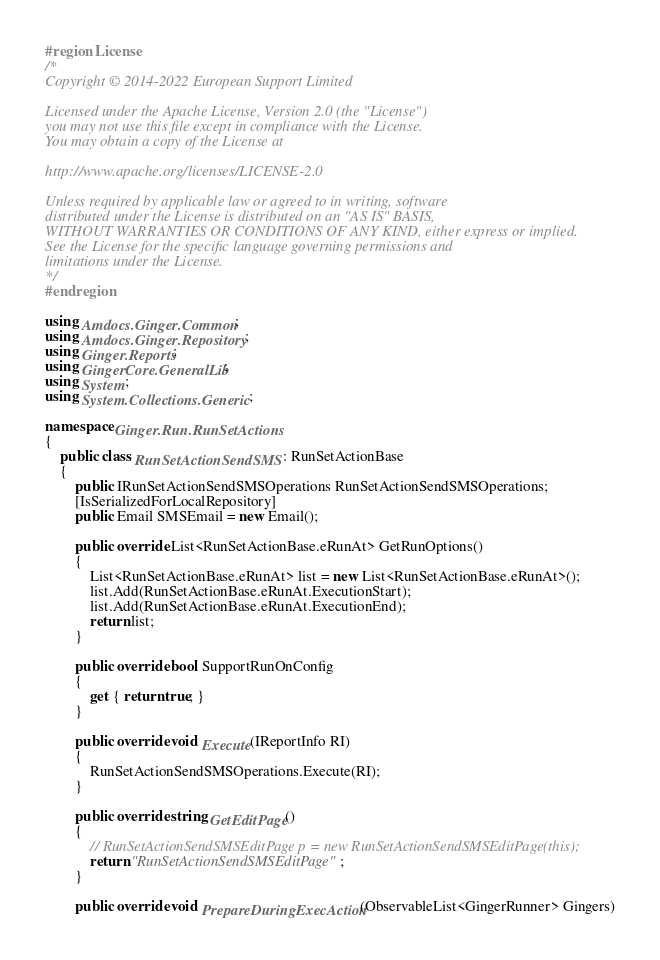<code> <loc_0><loc_0><loc_500><loc_500><_C#_>#region License
/*
Copyright © 2014-2022 European Support Limited

Licensed under the Apache License, Version 2.0 (the "License")
you may not use this file except in compliance with the License.
You may obtain a copy of the License at 

http://www.apache.org/licenses/LICENSE-2.0 

Unless required by applicable law or agreed to in writing, software
distributed under the License is distributed on an "AS IS" BASIS, 
WITHOUT WARRANTIES OR CONDITIONS OF ANY KIND, either express or implied. 
See the License for the specific language governing permissions and 
limitations under the License. 
*/
#endregion

using Amdocs.Ginger.Common;
using Amdocs.Ginger.Repository;
using Ginger.Reports;
using GingerCore.GeneralLib;
using System;
using System.Collections.Generic;

namespace Ginger.Run.RunSetActions
{
    public class RunSetActionSendSMS : RunSetActionBase
    {
        public IRunSetActionSendSMSOperations RunSetActionSendSMSOperations;
        [IsSerializedForLocalRepository]
        public Email SMSEmail = new Email();
      
        public override List<RunSetActionBase.eRunAt> GetRunOptions()
        {
            List<RunSetActionBase.eRunAt> list = new List<RunSetActionBase.eRunAt>();
            list.Add(RunSetActionBase.eRunAt.ExecutionStart);
            list.Add(RunSetActionBase.eRunAt.ExecutionEnd);
            return list;
        }

        public override bool SupportRunOnConfig
        {
            get { return true; }
        }
      
        public override void Execute(IReportInfo RI)
        {
            RunSetActionSendSMSOperations.Execute(RI);
        }

        public override string GetEditPage()
        {
            // RunSetActionSendSMSEditPage p = new RunSetActionSendSMSEditPage(this);
            return "RunSetActionSendSMSEditPage";
        }

        public override void PrepareDuringExecAction(ObservableList<GingerRunner> Gingers)</code> 